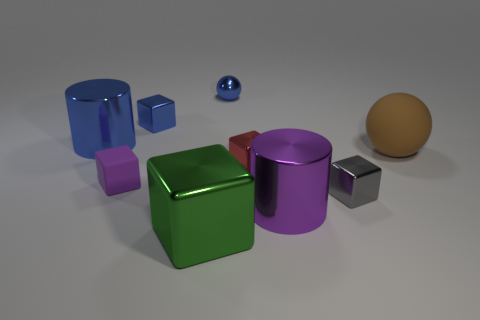Do the small metal object that is on the left side of the tiny blue metal sphere and the large cylinder that is in front of the gray block have the same color?
Offer a terse response. No. Are there any other things that have the same material as the purple cube?
Your answer should be very brief. Yes. The gray shiny object that is the same shape as the tiny rubber thing is what size?
Give a very brief answer. Small. Are there more green metallic cubes that are on the right side of the brown matte object than rubber cubes?
Provide a short and direct response. No. Do the cylinder that is behind the small gray metallic thing and the tiny blue sphere have the same material?
Your answer should be very brief. Yes. There is a rubber object that is to the right of the small cube that is behind the large brown matte sphere that is behind the tiny red object; what size is it?
Your answer should be compact. Large. The red thing that is the same material as the blue cylinder is what size?
Offer a terse response. Small. What is the color of the shiny object that is both left of the green shiny cube and in front of the tiny blue cube?
Offer a terse response. Blue. Is the number of small green matte cylinders the same as the number of large blocks?
Offer a very short reply. No. Do the blue thing that is left of the small purple block and the small blue thing that is to the left of the green metal thing have the same shape?
Your response must be concise. No. 